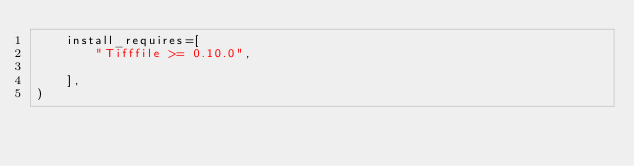Convert code to text. <code><loc_0><loc_0><loc_500><loc_500><_Python_>    install_requires=[
        "Tifffile >= 0.10.0",
    
    ],
)</code> 